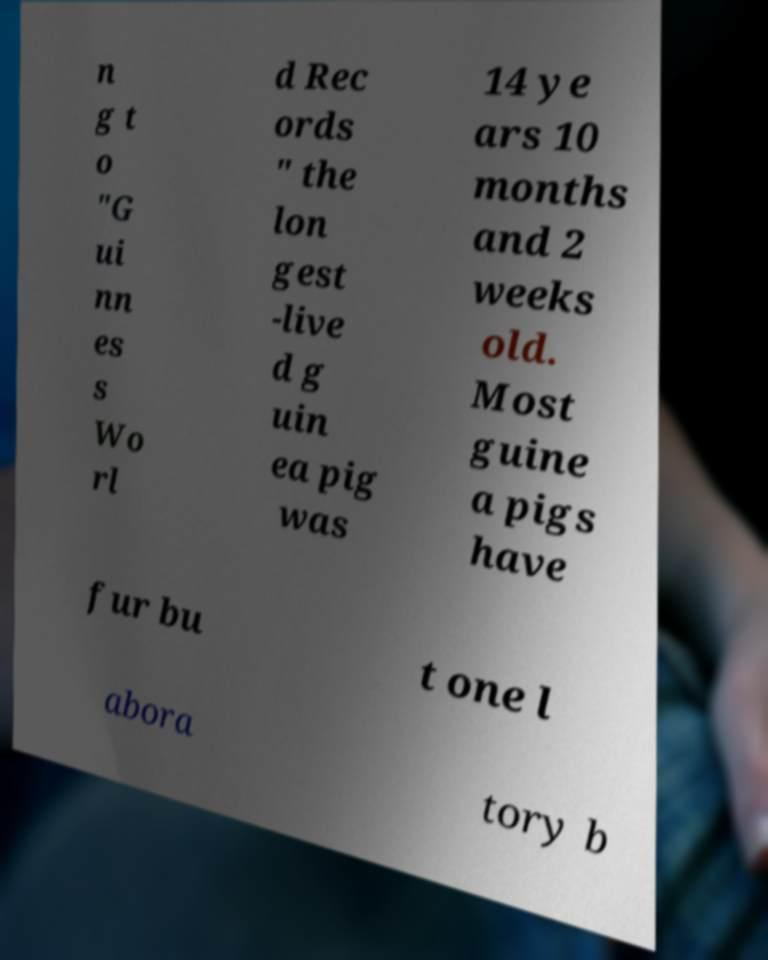Can you read and provide the text displayed in the image?This photo seems to have some interesting text. Can you extract and type it out for me? n g t o "G ui nn es s Wo rl d Rec ords " the lon gest -live d g uin ea pig was 14 ye ars 10 months and 2 weeks old. Most guine a pigs have fur bu t one l abora tory b 